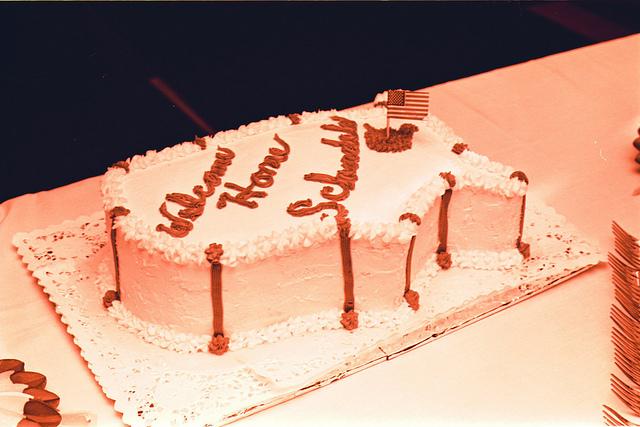What is the cake in celebration of?
Quick response, please. Welcome home. Is this cake in the shape of a country?
Short answer required. Yes. Are there candles on the cake?
Concise answer only. No. 